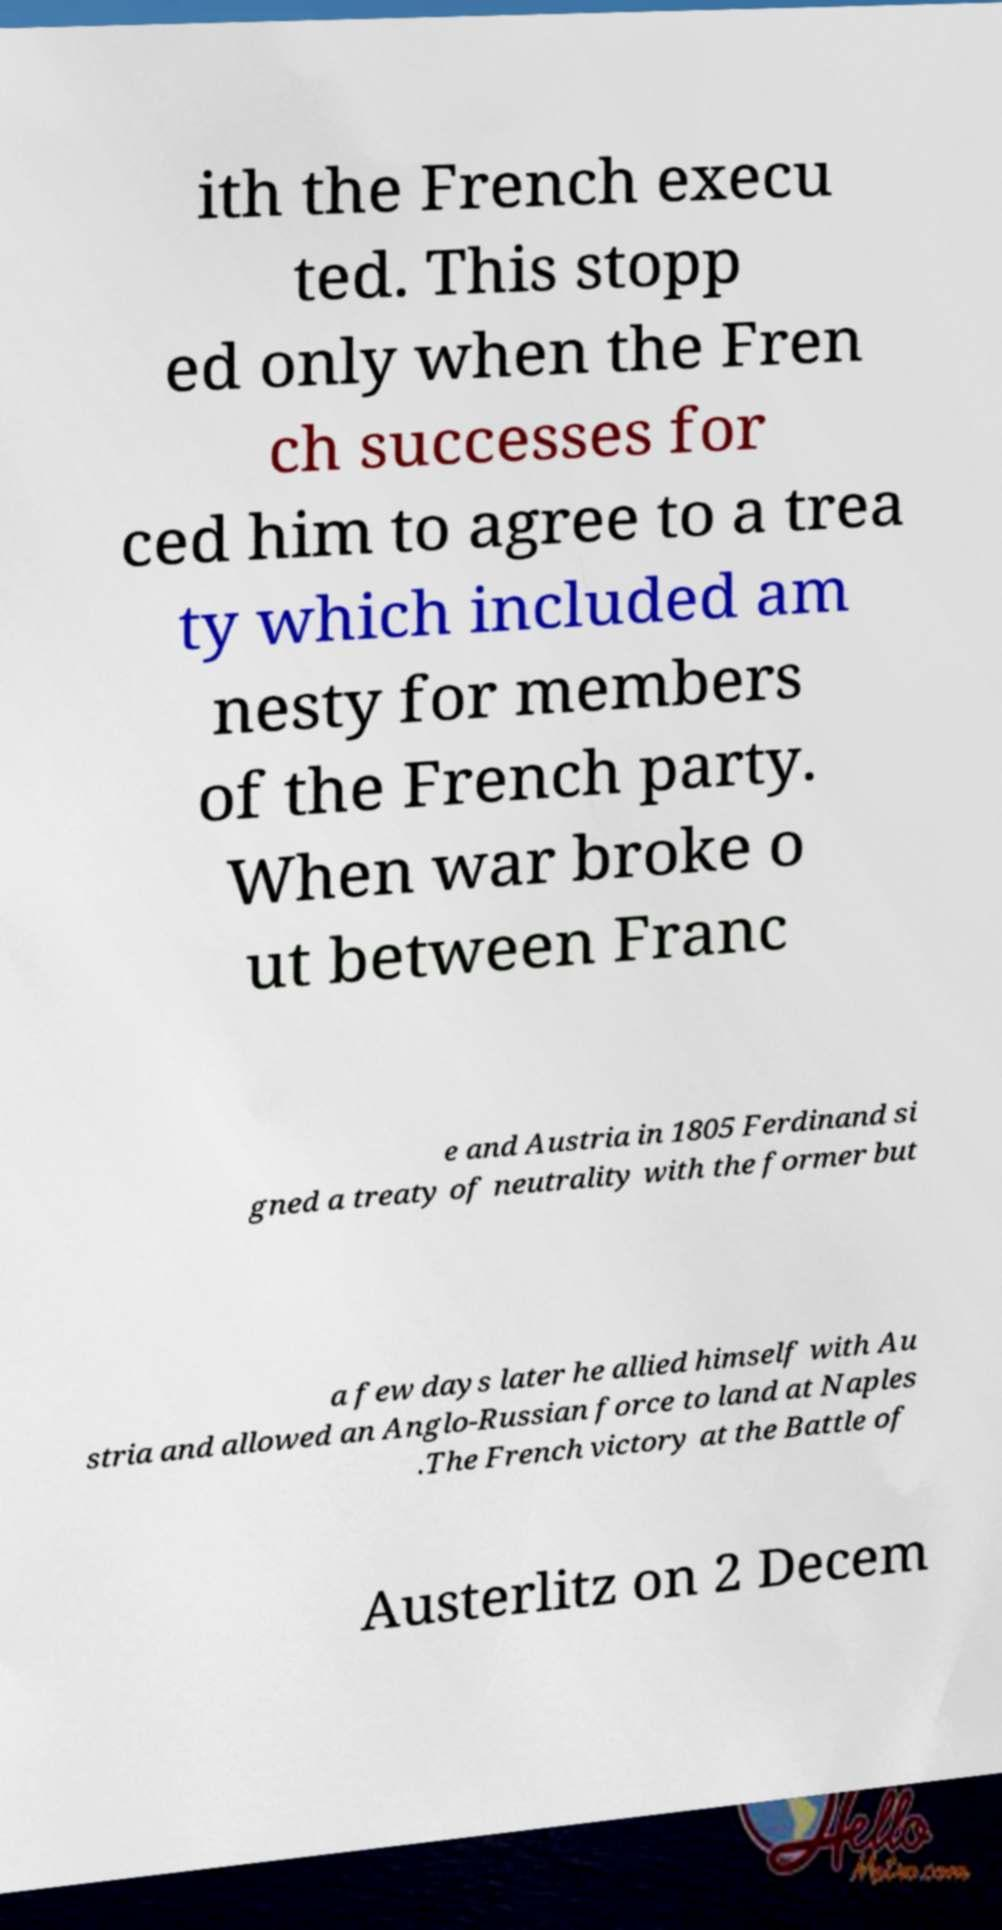Please read and relay the text visible in this image. What does it say? ith the French execu ted. This stopp ed only when the Fren ch successes for ced him to agree to a trea ty which included am nesty for members of the French party. When war broke o ut between Franc e and Austria in 1805 Ferdinand si gned a treaty of neutrality with the former but a few days later he allied himself with Au stria and allowed an Anglo-Russian force to land at Naples .The French victory at the Battle of Austerlitz on 2 Decem 